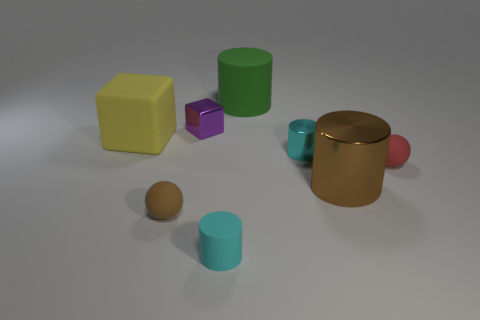Can you tell me which objects are similar in shape? Certainly! The green and teal objects are both cylinders, though the teal one is shorter. Similarly, the two spheres—one brown and one red—share the same shape but differ in color and size. And the materials? Which ones look similar? The golden cylinder and the red sphere both have reflective surfaces that suggest they're made of a metallic or glossy material. In contrast, the yellow block and purple cube appear matte, likely indicating a more diffused texture. 